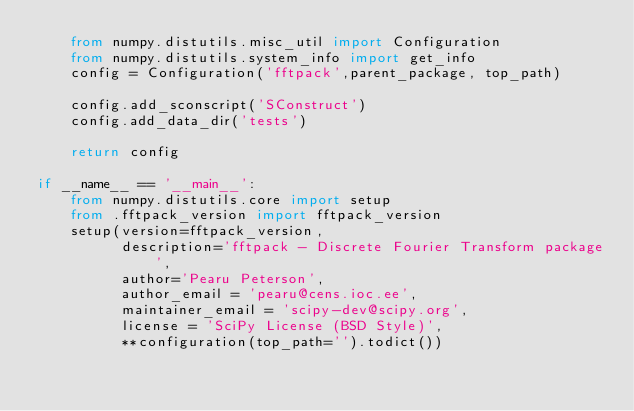Convert code to text. <code><loc_0><loc_0><loc_500><loc_500><_Python_>    from numpy.distutils.misc_util import Configuration
    from numpy.distutils.system_info import get_info
    config = Configuration('fftpack',parent_package, top_path)

    config.add_sconscript('SConstruct')
    config.add_data_dir('tests')

    return config

if __name__ == '__main__':
    from numpy.distutils.core import setup
    from .fftpack_version import fftpack_version
    setup(version=fftpack_version,
          description='fftpack - Discrete Fourier Transform package',
          author='Pearu Peterson',
          author_email = 'pearu@cens.ioc.ee',
          maintainer_email = 'scipy-dev@scipy.org',
          license = 'SciPy License (BSD Style)',
          **configuration(top_path='').todict())
</code> 